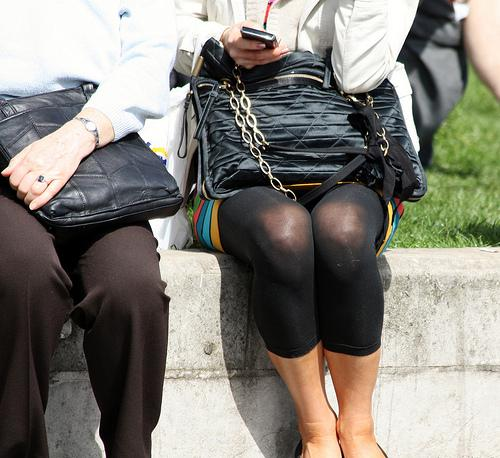Question: where are these women sitting?
Choices:
A. At a counter.
B. On a wall.
C. On the ground.
D. On a bench.
Answer with the letter. Answer: B Question: who are pictured?
Choices:
A. Two men.
B. Young girls.
C. Two women.
D. One man and one woman.
Answer with the letter. Answer: C Question: what color is the handle on the purse on the right?
Choices:
A. Silver chain.
B. Gold chain.
C. Brown strap.
D. Black strap.
Answer with the letter. Answer: B 